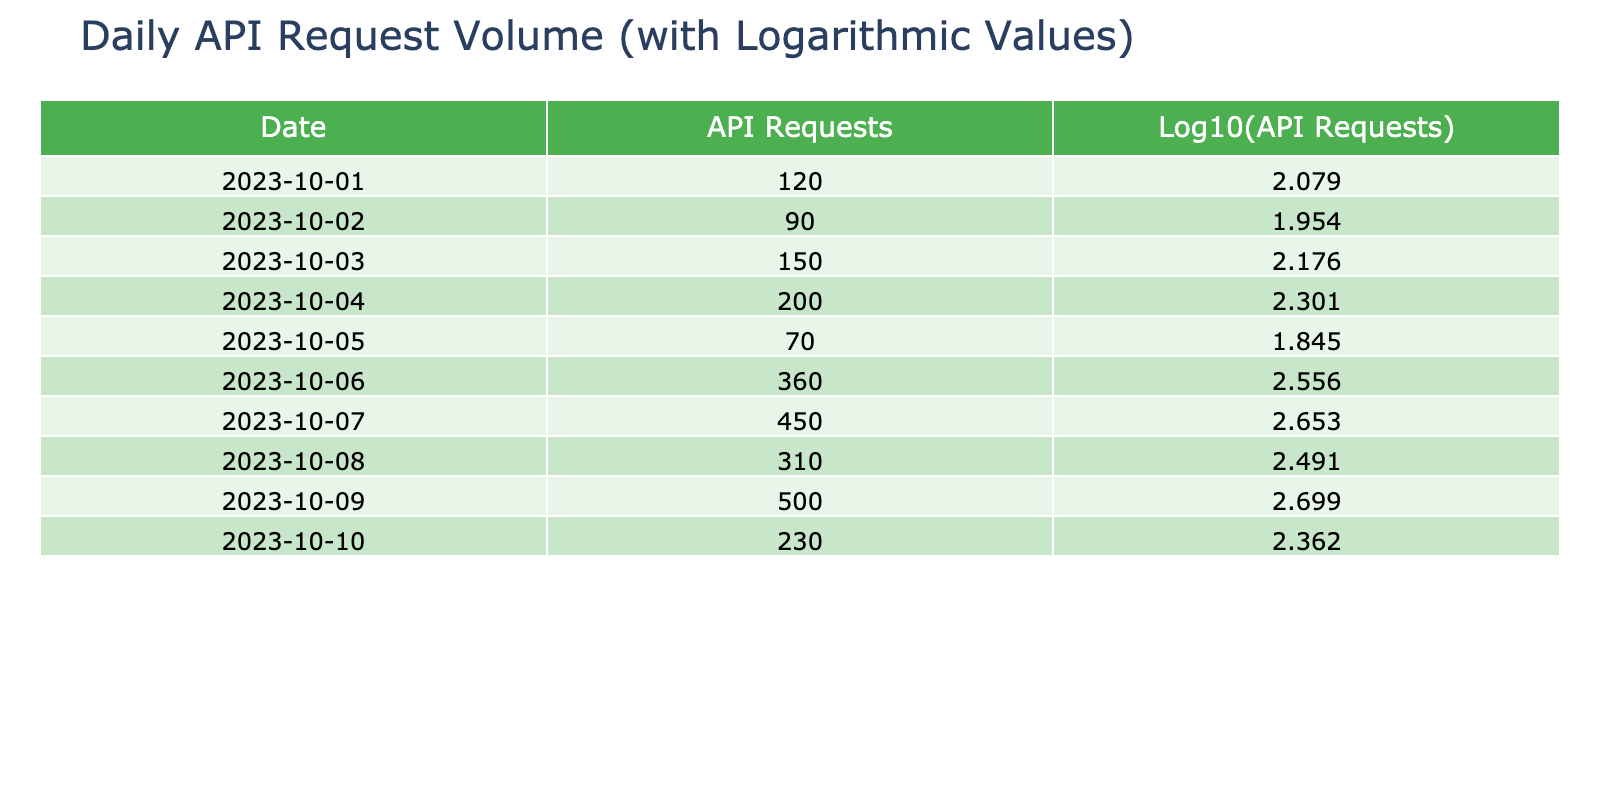What was the total number of API requests on 2023-10-06? The table shows that on 2023-10-06, the number of API requests was 360.
Answer: 360 What is the logarithmic value of API requests on 2023-10-04? According to the table, the logarithmic value of API requests for that date is approximately 2.301.
Answer: 2.301 What is the average number of API requests over the entire period? To find the average, we sum the API requests: 120 + 90 + 150 + 200 + 70 + 360 + 450 + 310 + 500 + 230 = 2480. There are 10 days, so the average is 2480 / 10 = 248.
Answer: 248 Did the API request volume exceed 400 on any day during this period? By checking the table, we see that on 2023-10-07 and 2023-10-09, the request volume was 450 and 500, respectively, both exceeding 400.
Answer: Yes On which date did the API request volume experience the largest increase compared to the previous day? To determine this, we look for the largest difference between consecutive days. The greatest increase is from 2023-10-05 (70) to 2023-10-06 (360), which is an increase of 290.
Answer: 2023-10-06 What is the difference in logarithmic values between the highest and lowest API requests? The highest API requests were 500 on 2023-10-09, with a log value of approximately 2.699. The lowest was 70 on 2023-10-05, with a log value of approximately 1.845. The difference is 2.699 - 1.845 = 0.854.
Answer: 0.854 Was there any day where the number of requests was less than 100? Based on the table data, the only day with requests below 100 was on 2023-10-02, where there were 90 requests.
Answer: Yes What was the lowest logarithmic value recorded in the table? The lowest logarithmic value corresponds to the API requests on 2023-10-05, which had 70 requests, resulting in a log value of approximately 1.845.
Answer: 1.845 Which date recorded the highest volume of API requests and what was the volume? The highest recorded API requests occurred on 2023-10-09 with a total of 500 requests.
Answer: 2023-10-09, 500 